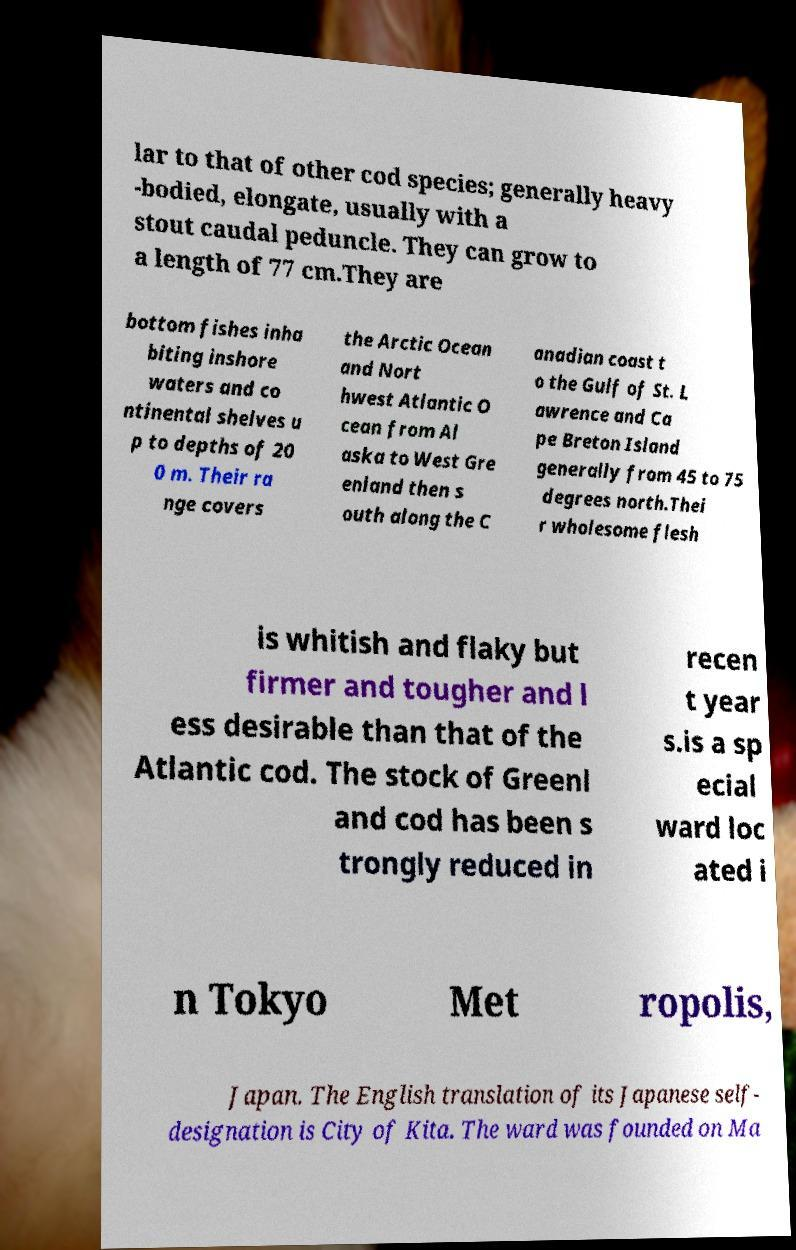Could you extract and type out the text from this image? lar to that of other cod species; generally heavy -bodied, elongate, usually with a stout caudal peduncle. They can grow to a length of 77 cm.They are bottom fishes inha biting inshore waters and co ntinental shelves u p to depths of 20 0 m. Their ra nge covers the Arctic Ocean and Nort hwest Atlantic O cean from Al aska to West Gre enland then s outh along the C anadian coast t o the Gulf of St. L awrence and Ca pe Breton Island generally from 45 to 75 degrees north.Thei r wholesome flesh is whitish and flaky but firmer and tougher and l ess desirable than that of the Atlantic cod. The stock of Greenl and cod has been s trongly reduced in recen t year s.is a sp ecial ward loc ated i n Tokyo Met ropolis, Japan. The English translation of its Japanese self- designation is City of Kita. The ward was founded on Ma 